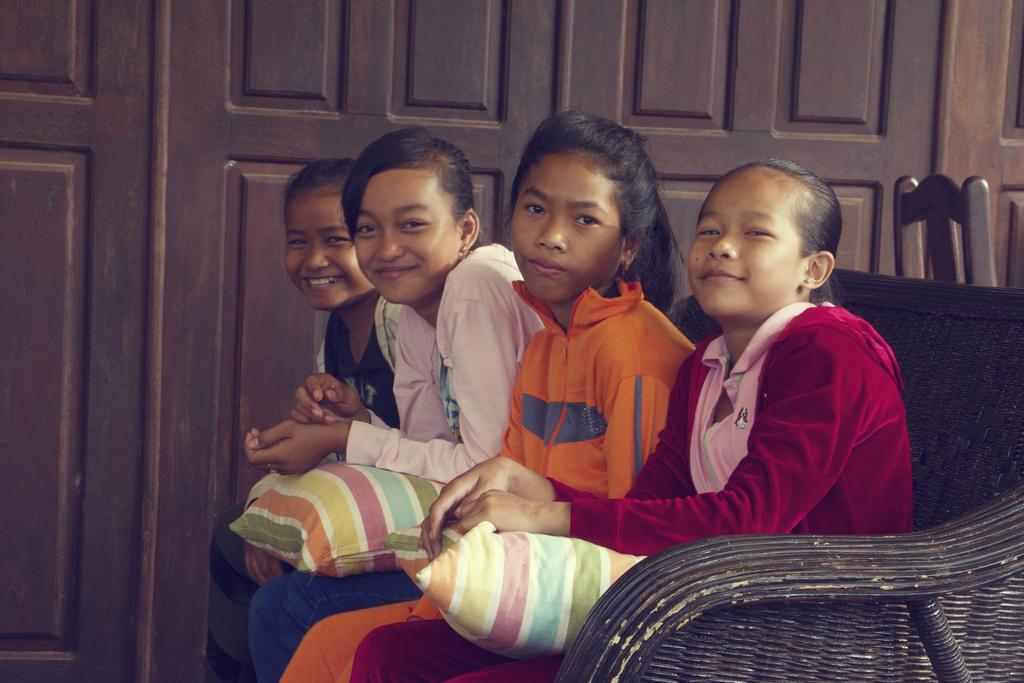What type of furniture is in the image? There is a sofa in the image. Who or what is on the sofa? There are children sitting on the sofa. What can be seen in the background of the image? There is a wooden wall in the background of the image. What type of snake can be seen slithering on the slope in the image? There is no snake or slope present in the image; it features a sofa with children sitting on it and a wooden wall in the background. 